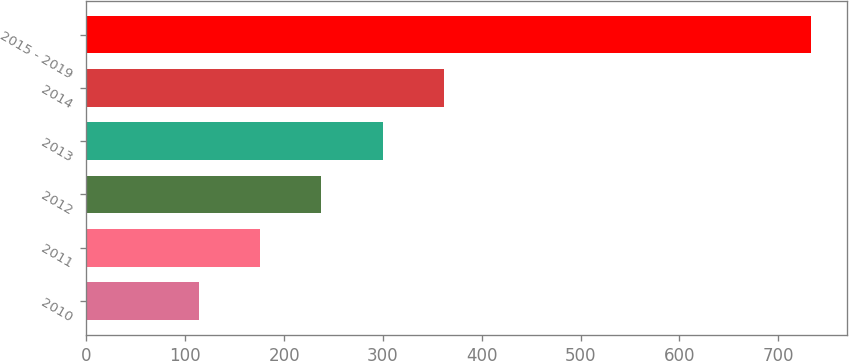Convert chart to OTSL. <chart><loc_0><loc_0><loc_500><loc_500><bar_chart><fcel>2010<fcel>2011<fcel>2012<fcel>2013<fcel>2014<fcel>2015 - 2019<nl><fcel>114<fcel>175.9<fcel>237.8<fcel>299.7<fcel>361.6<fcel>733<nl></chart> 